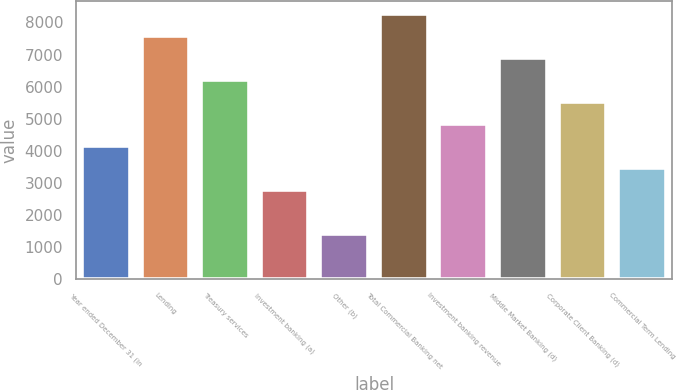Convert chart. <chart><loc_0><loc_0><loc_500><loc_500><bar_chart><fcel>Year ended December 31 (in<fcel>Lending<fcel>Treasury services<fcel>Investment banking (a)<fcel>Other (b)<fcel>Total Commercial Banking net<fcel>Investment banking revenue<fcel>Middle Market Banking (d)<fcel>Corporate Client Banking (d)<fcel>Commercial Term Lending<nl><fcel>4137<fcel>7572<fcel>6198<fcel>2763<fcel>1389<fcel>8259<fcel>4824<fcel>6885<fcel>5511<fcel>3450<nl></chart> 